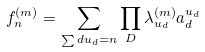<formula> <loc_0><loc_0><loc_500><loc_500>f _ { n } ^ { ( m ) } = \sum _ { \sum d u _ { d } = n } \prod _ { D } \lambda _ { u _ { d } } ^ { ( m ) } a _ { d } ^ { u _ { d } }</formula> 